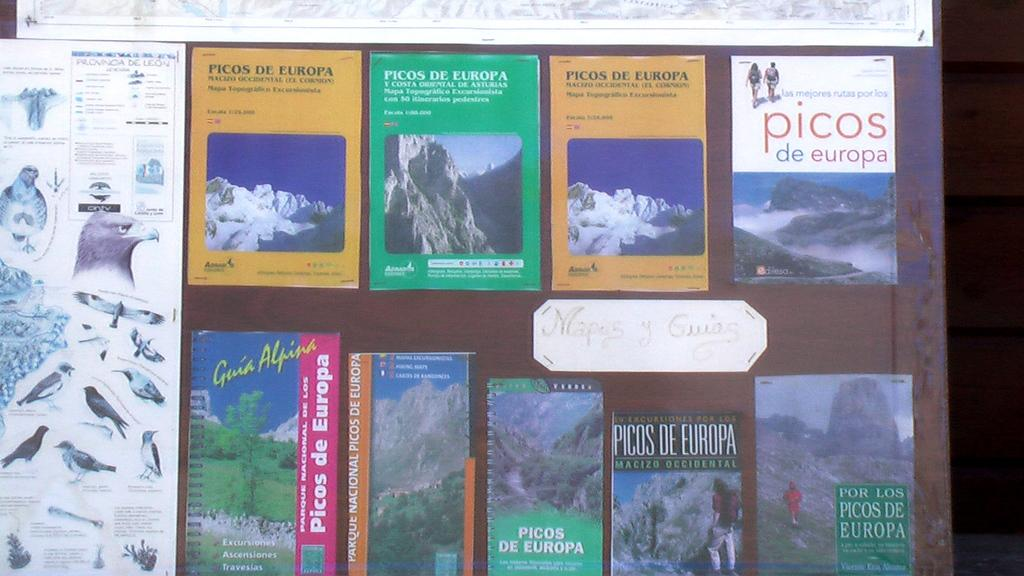<image>
Summarize the visual content of the image. A display of magazines and travel guides that are titled picos de europa 